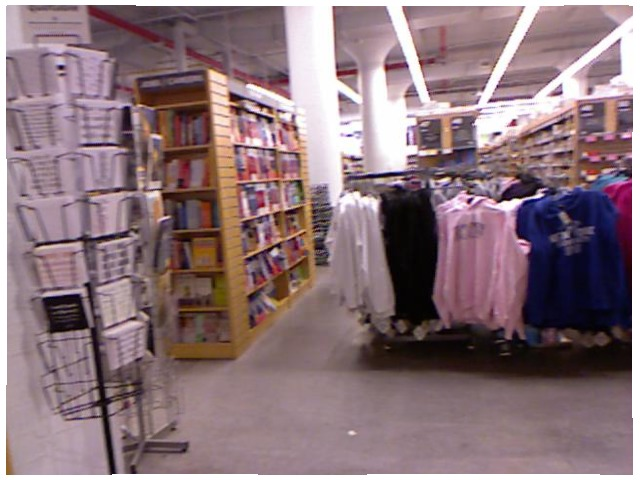<image>
Can you confirm if the book is on the shelf? Yes. Looking at the image, I can see the book is positioned on top of the shelf, with the shelf providing support. Is there a blue shirt on the floor? No. The blue shirt is not positioned on the floor. They may be near each other, but the blue shirt is not supported by or resting on top of the floor. 